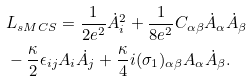<formula> <loc_0><loc_0><loc_500><loc_500>& L _ { s M C S } = \frac { 1 } { 2 e ^ { 2 } } \dot { A } ^ { 2 } _ { i } + \frac { 1 } { 8 e ^ { 2 } } C _ { \alpha \beta } \dot { A } _ { \alpha } \dot { A } _ { \beta } \\ & - \frac { \kappa } { 2 } \epsilon _ { i j } A _ { i } \dot { A } _ { j } + \frac { \kappa } { 4 } i ( \sigma _ { 1 } ) _ { \alpha \beta } A _ { \alpha } \dot { A } _ { \beta } .</formula> 